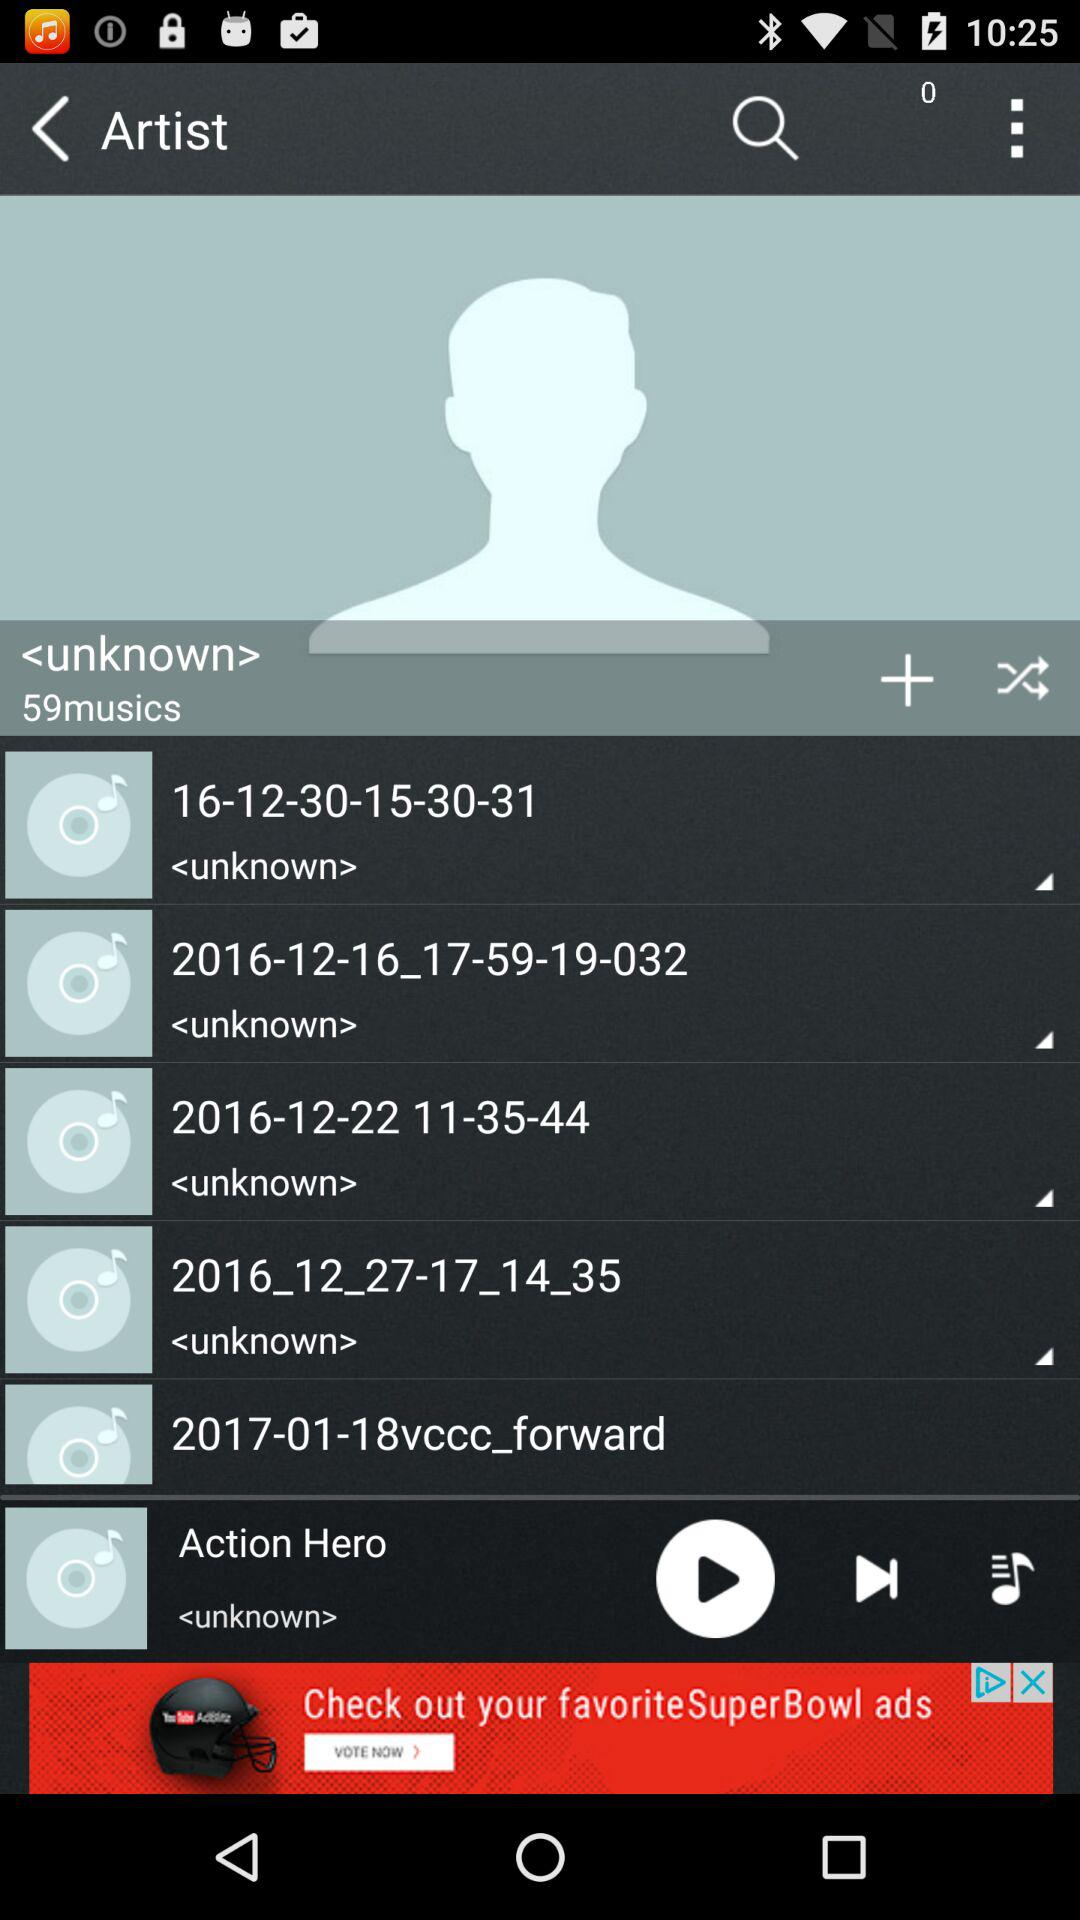Which music was last played? The last played music was "Action Hero". 